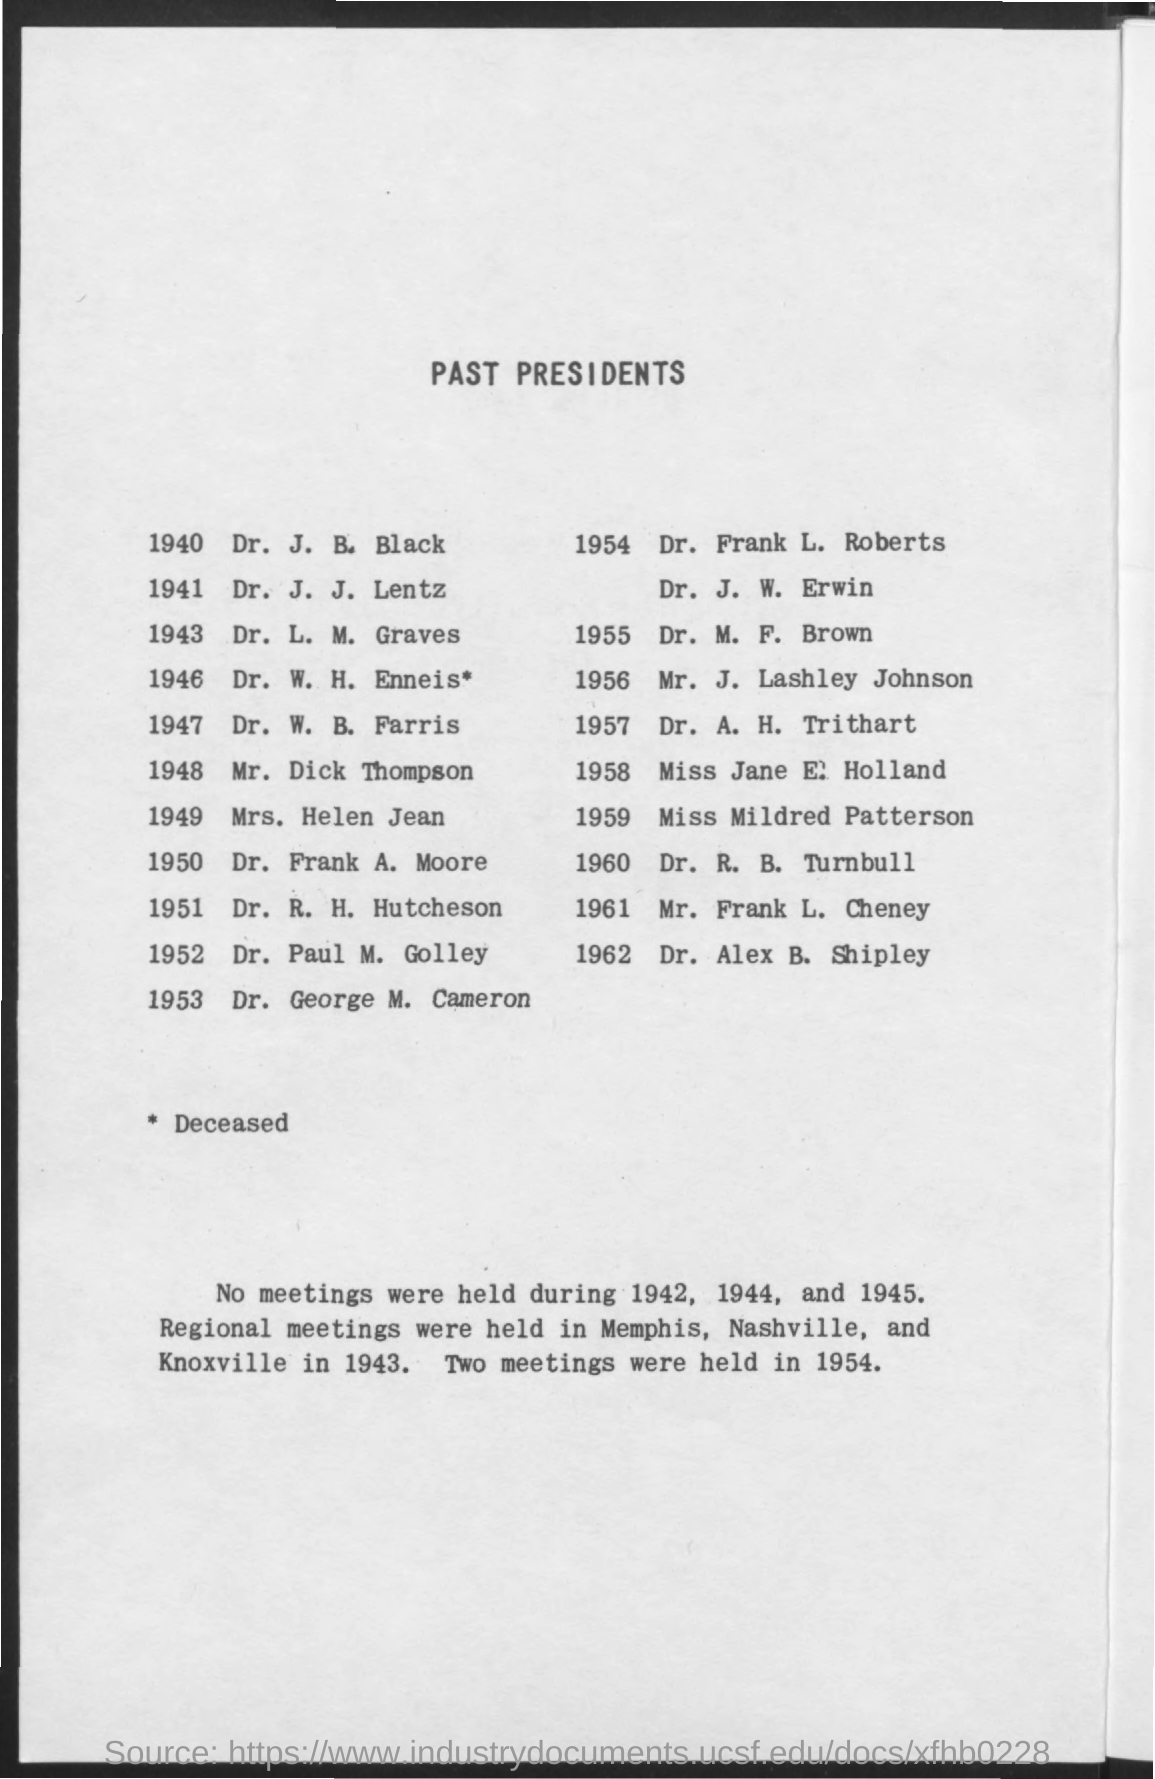What is the title of the document?
Ensure brevity in your answer.  Past presidents. Two meetings are held in which year?
Provide a succinct answer. 1954. 